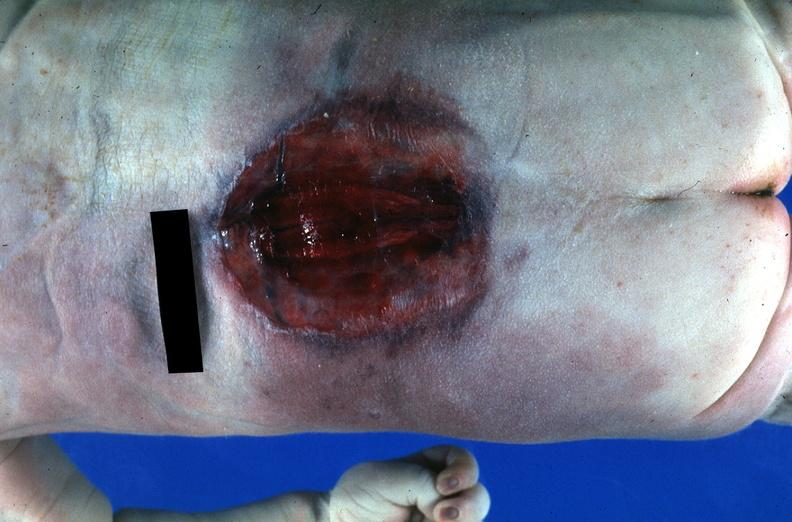what does this image show?
Answer the question using a single word or phrase. Neural tube defect 